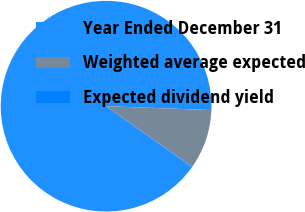<chart> <loc_0><loc_0><loc_500><loc_500><pie_chart><fcel>Year Ended December 31<fcel>Weighted average expected<fcel>Expected dividend yield<nl><fcel>90.75%<fcel>9.16%<fcel>0.09%<nl></chart> 